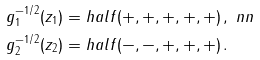Convert formula to latex. <formula><loc_0><loc_0><loc_500><loc_500>g _ { 1 } ^ { - 1 / 2 } ( z _ { 1 } ) = & \ h a l f ( + , + , + , + , + ) \, , \ n n \\ g _ { 2 } ^ { - 1 / 2 } ( z _ { 2 } ) = & \ h a l f ( - , - , + , + , + ) \, .</formula> 